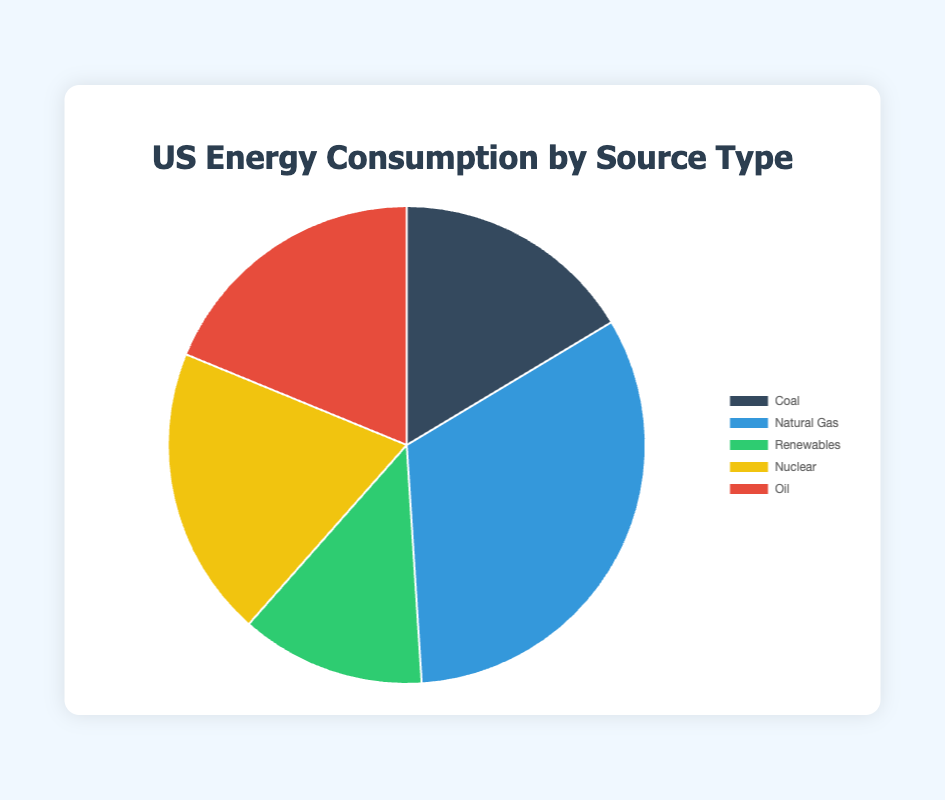What is the largest source of energy consumption in the US? The largest source can be identified by comparing the values in the pie chart. Natural Gas has the highest percentage at 32.6%.
Answer: Natural Gas How much more energy consumption comes from Natural Gas compared to Coal? Subtract the percentage of Coal from the percentage of Natural Gas: 32.6% - 16.4% = 16.2%.
Answer: 16.2% What is the total percentage of energy consumption from non-renewable sources? Sum the percentages of Coal, Natural Gas, Nuclear, and Oil: 16.4% + 32.6% + 19.7% + 18.8% = 87.5%.
Answer: 87.5% What is the difference in energy consumption between Nuclear and Oil? Subtract the percentage of Oil from the percentage of Nuclear: 19.7% - 18.8% = 0.9%.
Answer: 0.9% Which renewable source has the highest contribution to energy consumption? By comparing the detailed values for each renewable source, Wind has the highest at 7.8%.
Answer: Wind By how much does Renewable energy consumption exceed Coal energy consumption? Subtract the percentage of Coal from the total Renewables: 12.5% - 16.4% = -3.9%, hence, Coal exceeds Renewables.
Answer: -3.9% What is the combined energy consumption from Renewable and Nuclear sources? Sum the percentages of Renewables and Nuclear: 12.5% + 19.7% = 32.2%.
Answer: 32.2% Which source has the lowest energy consumption? Among the percentages displayed, Renewable sources have the smallest contribution at 12.5%.
Answer: Renewables What is the percentage difference between the most consumed and least consumed energy sources? Subtract the smallest percentage (Renewables) from the largest percentage (Natural Gas): 32.6% - 12.5% = 20.1%.
Answer: 20.1% What is the average energy consumption of Coal, Natural Gas, and Oil? Sum their percentages and divide by 3: (16.4% + 32.6% + 18.8%) / 3 = 22.6%.
Answer: 22.6% 